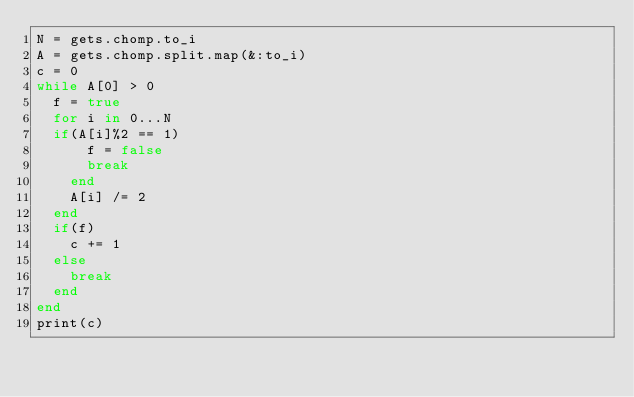Convert code to text. <code><loc_0><loc_0><loc_500><loc_500><_Ruby_>N = gets.chomp.to_i
A = gets.chomp.split.map(&:to_i)
c = 0
while A[0] > 0
  f = true
  for i in 0...N
	if(A[i]%2 == 1)
      f = false
      break
    end
    A[i] /= 2
  end
  if(f)
    c += 1
  else
    break
  end
end
print(c)</code> 